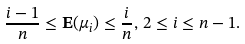Convert formula to latex. <formula><loc_0><loc_0><loc_500><loc_500>\frac { i - 1 } { n } \leq { \mathbf E } ( \mu _ { i } ) \leq \frac { i } { n } , \, 2 \leq i \leq n - 1 .</formula> 